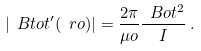<formula> <loc_0><loc_0><loc_500><loc_500>| \ B t o t ^ { \prime } ( \ r o ) | = \frac { 2 \pi } { \mu o } \frac { \ B o t ^ { 2 } } { I } \, .</formula> 